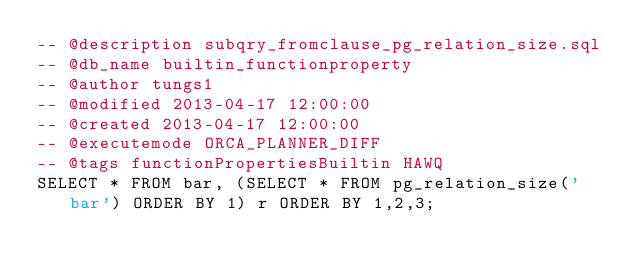<code> <loc_0><loc_0><loc_500><loc_500><_SQL_>-- @description subqry_fromclause_pg_relation_size.sql
-- @db_name builtin_functionproperty
-- @author tungs1
-- @modified 2013-04-17 12:00:00
-- @created 2013-04-17 12:00:00
-- @executemode ORCA_PLANNER_DIFF
-- @tags functionPropertiesBuiltin HAWQ
SELECT * FROM bar, (SELECT * FROM pg_relation_size('bar') ORDER BY 1) r ORDER BY 1,2,3;
</code> 